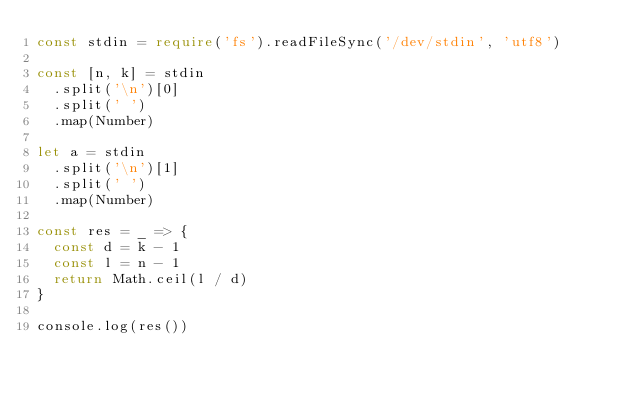Convert code to text. <code><loc_0><loc_0><loc_500><loc_500><_TypeScript_>const stdin = require('fs').readFileSync('/dev/stdin', 'utf8')

const [n, k] = stdin
  .split('\n')[0]
  .split(' ')
  .map(Number)

let a = stdin
  .split('\n')[1]
  .split(' ')
  .map(Number)

const res = _ => {
  const d = k - 1
  const l = n - 1
  return Math.ceil(l / d)
}

console.log(res())
</code> 